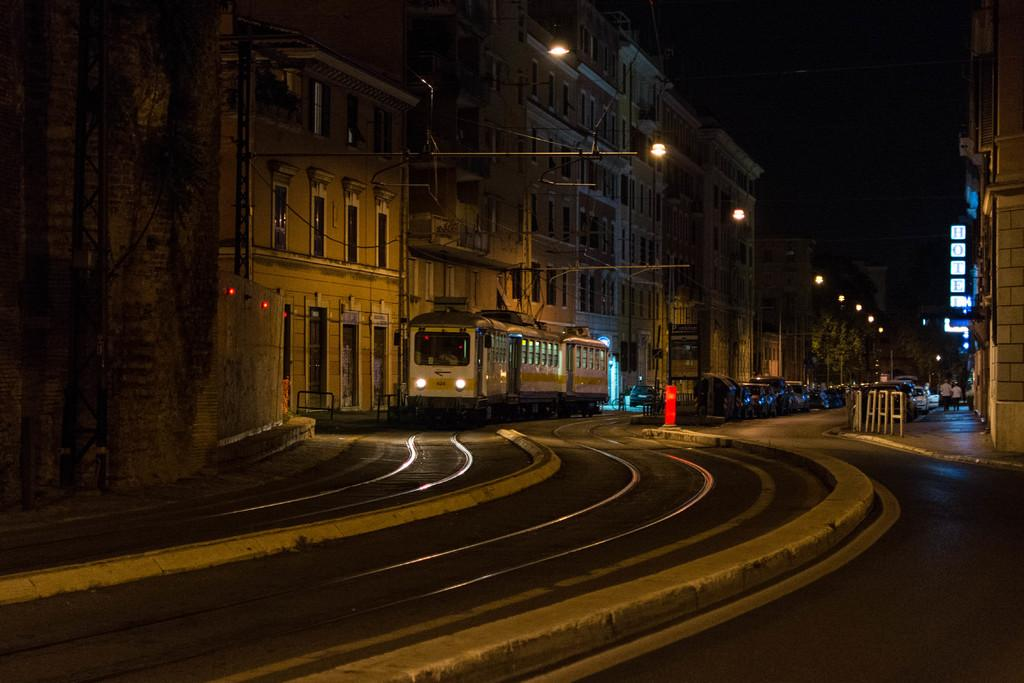What is the main subject of the image? The main subject of the image is a train on the track. What can be seen on either side of the train? There are buildings on either side of the train. What other types of transportation are visible in the image? There are vehicles visible in the image. What type of natural element is present in the image? There are trees present in the image. What type of art can be seen on the page in the image? There is no page or art present in the image; it features a train on the track with buildings, vehicles, and trees. 